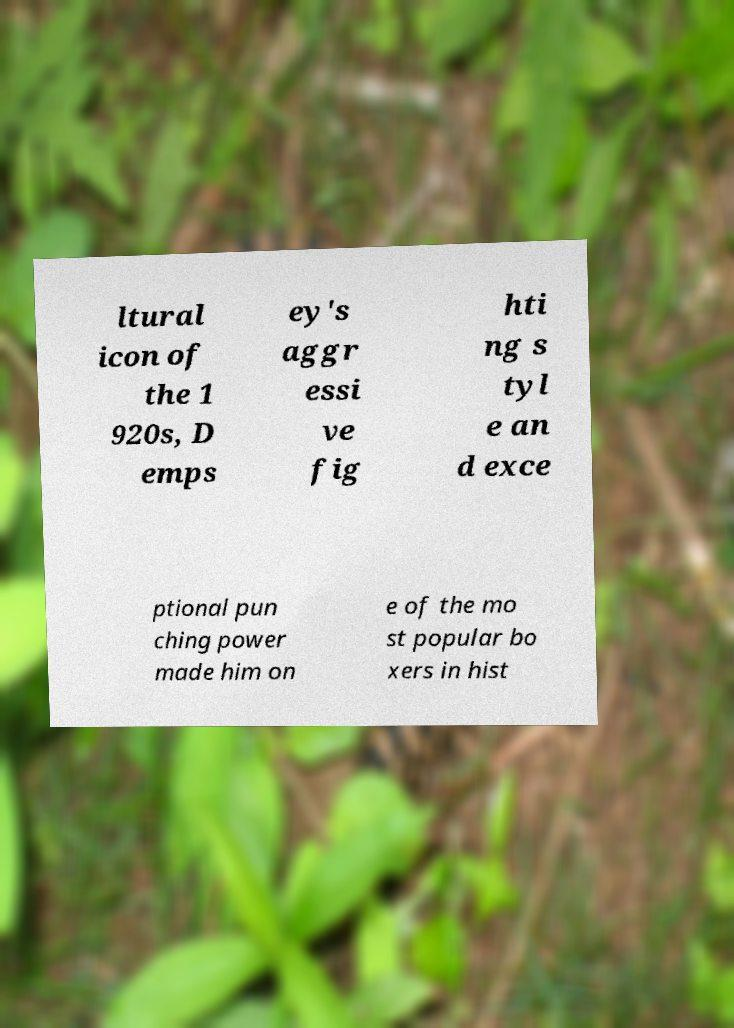There's text embedded in this image that I need extracted. Can you transcribe it verbatim? ltural icon of the 1 920s, D emps ey's aggr essi ve fig hti ng s tyl e an d exce ptional pun ching power made him on e of the mo st popular bo xers in hist 